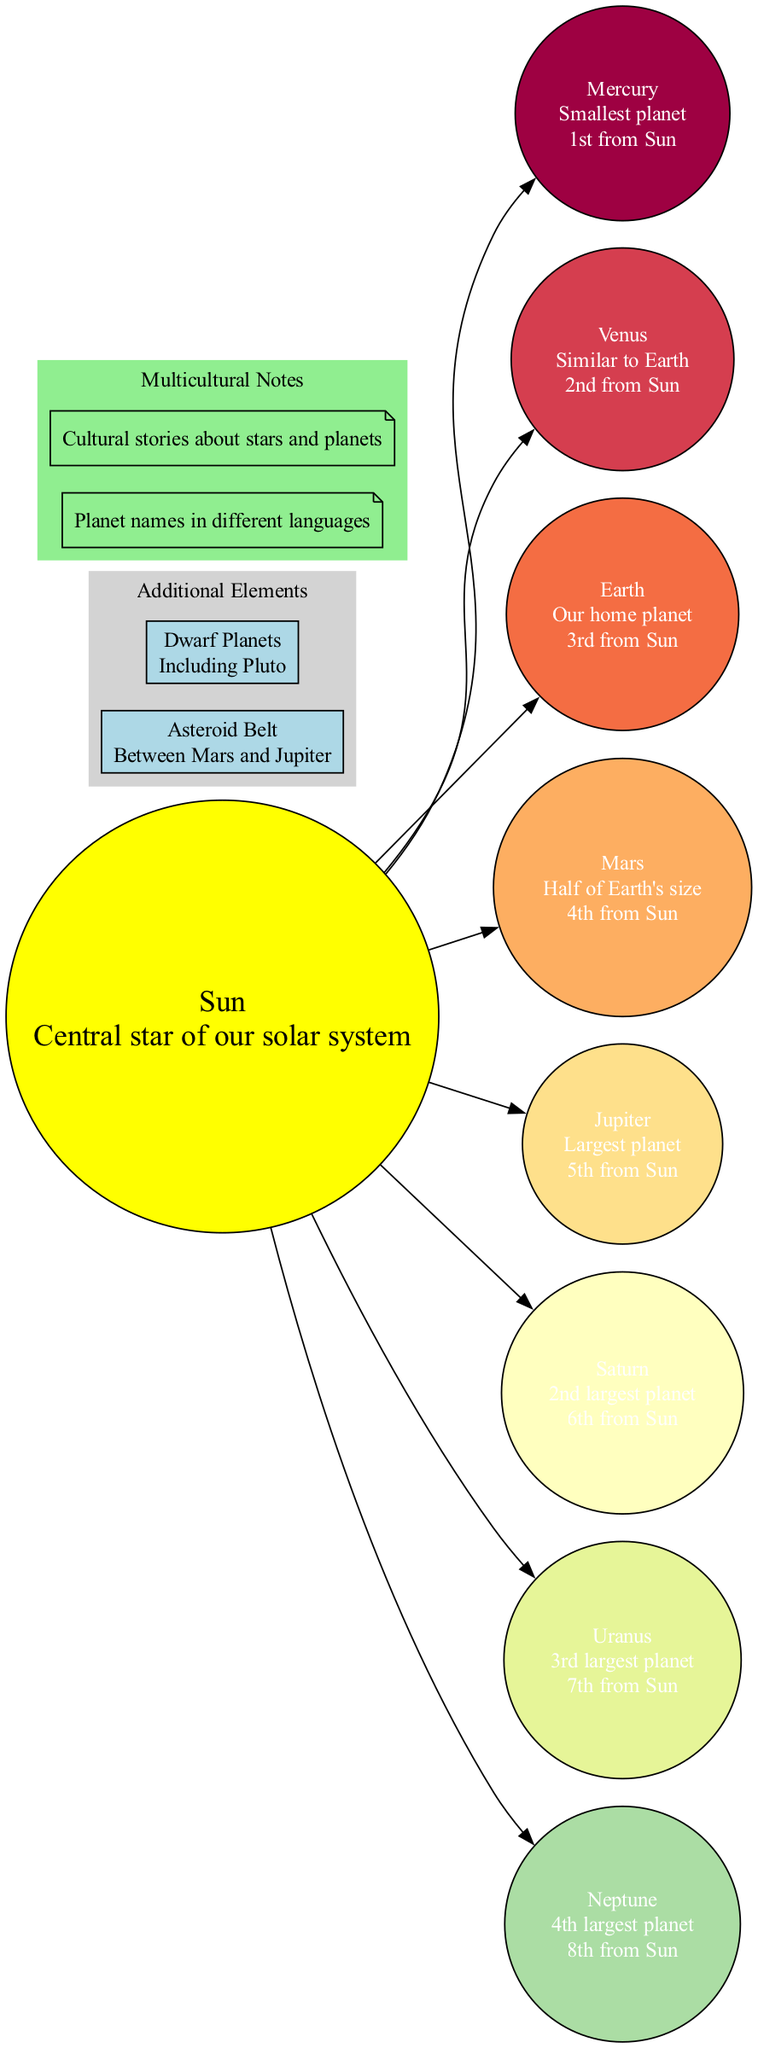What is the central object of the solar system? The diagram indicates that the central object is the "Sun." This is typically labeled in the central position in solar system diagrams.
Answer: Sun How many planets are shown in the diagram? By counting the individual planet nodes listed in the diagram, we find there are eight planets present: Mercury, Venus, Earth, Mars, Jupiter, Saturn, Uranus, and Neptune.
Answer: 8 Which planet is the largest? The diagram clearly states that "Jupiter" is identified as the "Largest planet," making it the largest planet in the solar system according to the provided data.
Answer: Jupiter What is the order of Mars from the Sun? The diagram specifies Mars is the "4th from Sun," which gives us the position of Mars in relation to the Sun.
Answer: 4th Which additional element is located between Mars and Jupiter? The diagram mentions an "Asteroid Belt" which is specifically described as being "Between Mars and Jupiter." This gives its specific location within the solar system context.
Answer: Asteroid Belt What size is Neptune relative to the largest planet? Neptune is described as the "4th largest planet," which means it compares in size relative to the larger planets, with Jupiter being the largest followed by Saturn, Uranus, and then Neptune.
Answer: 4th largest What cultural aspect is noted in the diagram related to the planets? The diagram includes a note about "Cultural stories about stars and planets," emphasizing the multicultural aspect of the lesson regarding celestial bodies.
Answer: Cultural stories about stars and planets Which planet is described as "Our home planet"? The diagram explicitly refers to "Earth" as "Our home planet," indicating its significance to humanity.
Answer: Earth How many languages are mentioned for the names of the planets? The diagram notes "Planet names in different languages," which indicates a focus on cultural integration through language, but does not specify a number, suggesting multiple languages could be involved.
Answer: Multiple languages 